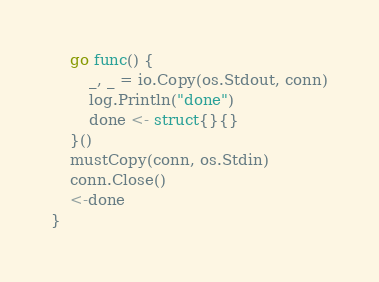<code> <loc_0><loc_0><loc_500><loc_500><_Go_>	go func() {
		_, _ = io.Copy(os.Stdout, conn)
		log.Println("done")
		done <- struct{}{}
	}()
	mustCopy(conn, os.Stdin)
	conn.Close()
	<-done
}
</code> 